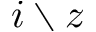<formula> <loc_0><loc_0><loc_500><loc_500>i \ z</formula> 